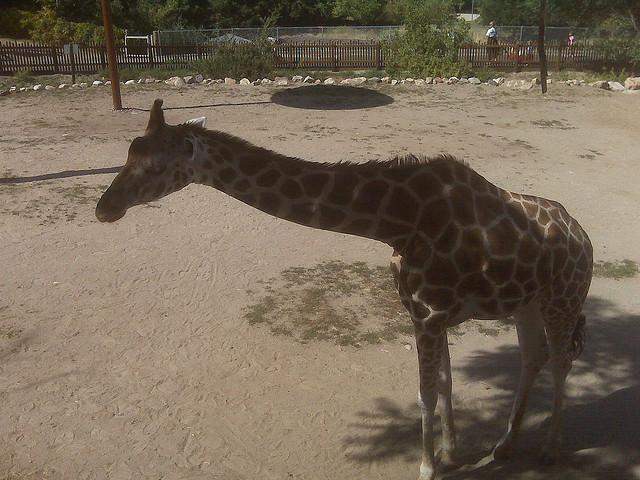Does the giraffe look tired?
Concise answer only. Yes. How many people are in this photo?
Write a very short answer. 4. Yes it does?
Keep it brief. Giraffe. 